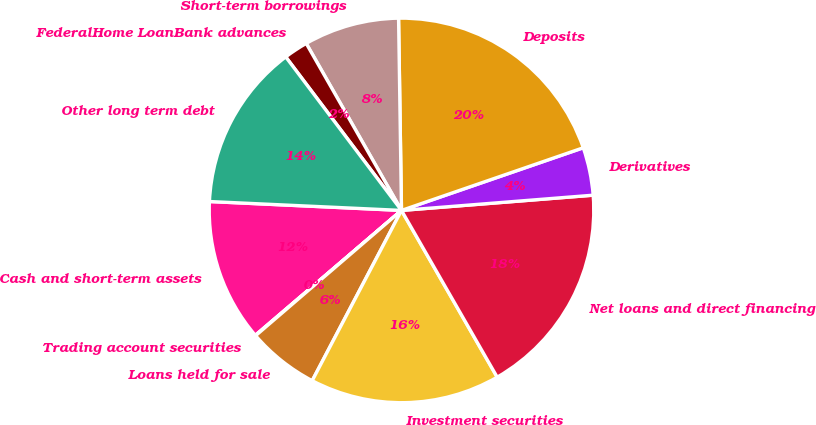<chart> <loc_0><loc_0><loc_500><loc_500><pie_chart><fcel>Cash and short-term assets<fcel>Trading account securities<fcel>Loans held for sale<fcel>Investment securities<fcel>Net loans and direct financing<fcel>Derivatives<fcel>Deposits<fcel>Short-term borrowings<fcel>FederalHome LoanBank advances<fcel>Other long term debt<nl><fcel>11.99%<fcel>0.04%<fcel>6.02%<fcel>15.98%<fcel>17.97%<fcel>4.02%<fcel>19.96%<fcel>8.01%<fcel>2.03%<fcel>13.98%<nl></chart> 